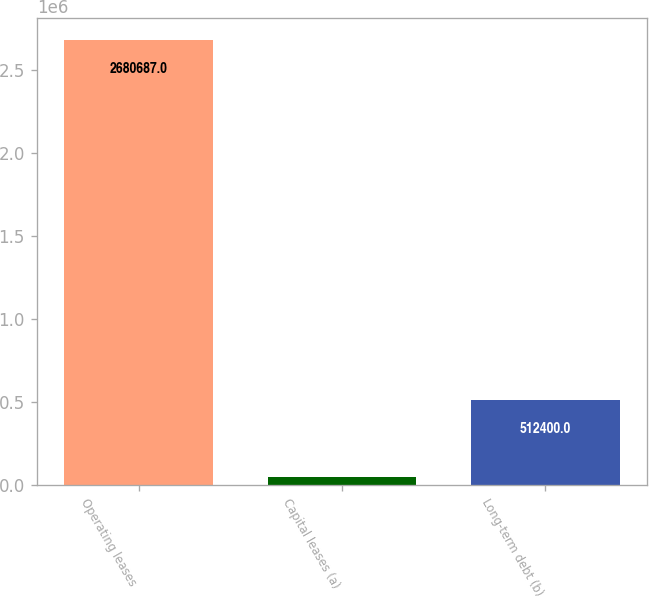<chart> <loc_0><loc_0><loc_500><loc_500><bar_chart><fcel>Operating leases<fcel>Capital leases (a)<fcel>Long-term debt (b)<nl><fcel>2.68069e+06<fcel>48265<fcel>512400<nl></chart> 